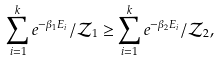Convert formula to latex. <formula><loc_0><loc_0><loc_500><loc_500>\sum _ { i = 1 } ^ { k } e ^ { - \beta _ { 1 } E _ { i } } / \mathcal { Z } _ { 1 } \geq \sum _ { i = 1 } ^ { k } e ^ { - \beta _ { 2 } E _ { i } } / \mathcal { Z } _ { 2 } ,</formula> 